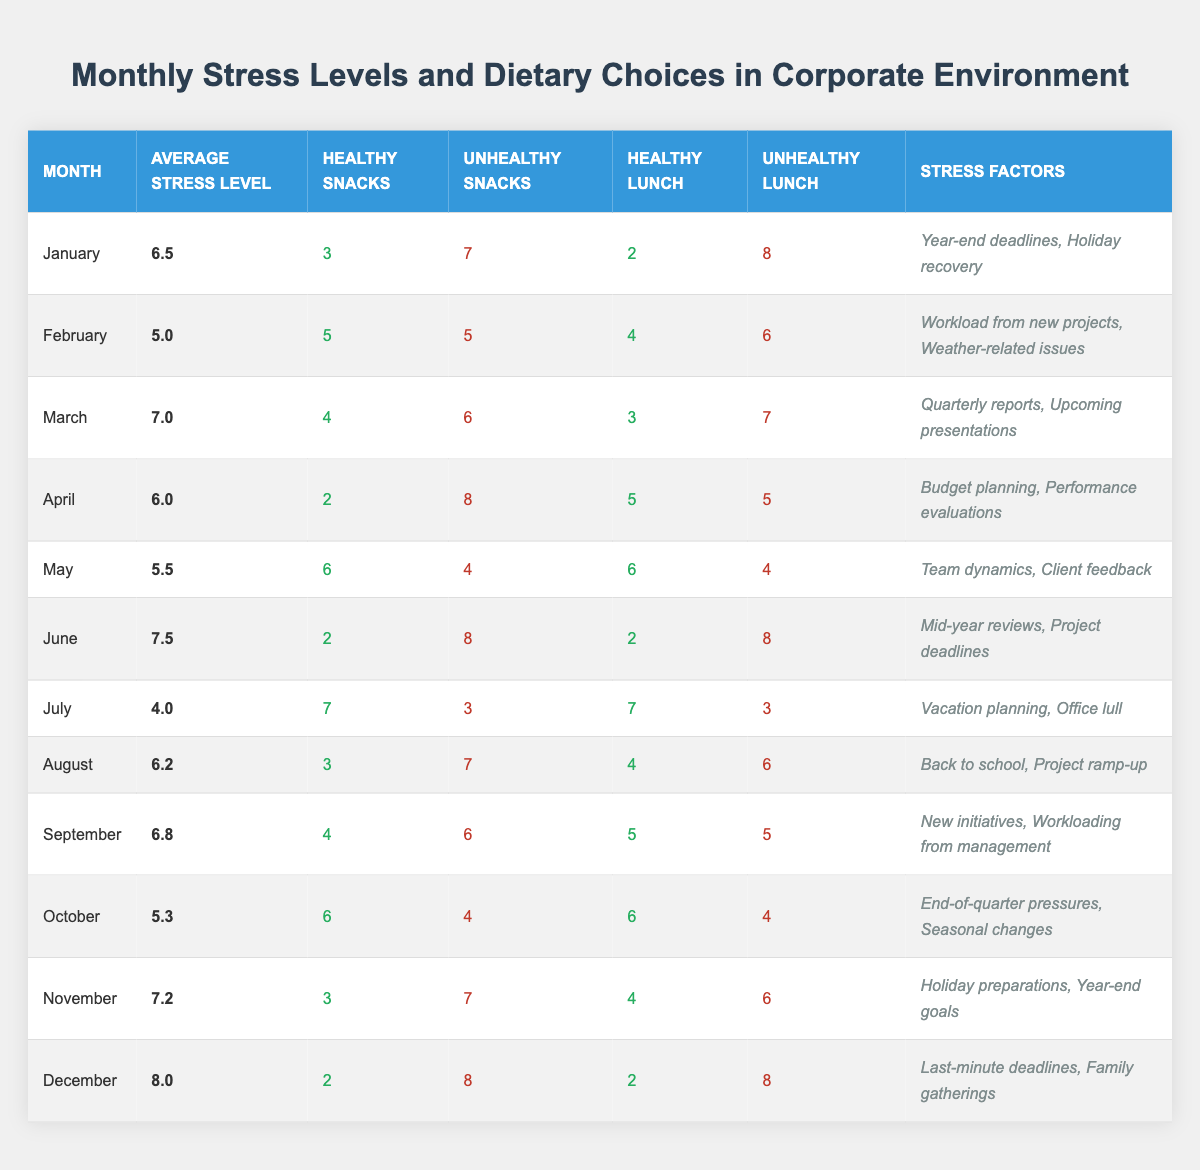What was the average stress level in February? In the table, the average stress level for February is listed directly in that row as 5.0.
Answer: 5.0 How many unhealthy snacks were consumed in March? Looking at the table for March, the number of unhealthy snacks is listed as 6.
Answer: 6 What is the average number of healthy lunch options across all months? To find the average, we sum the healthy lunch options for each month (2 + 4 + 3 + 5 + 6 + 2 + 7 + 4 + 5 + 6 + 4 + 2 = 58) and divide by the number of months (12). So, 58/12 = 4.83.
Answer: 4.83 In which month did the highest average stress level occur? The stress levels are compared, and December has the highest average stress level at 8.0, which is greater than all other months.
Answer: December How many months recorded an average stress level above 7.0? By checking the table, the months with stress levels above 7.0 are March (7.0), June (7.5), November (7.2), and December (8.0). This totals 4 months.
Answer: 4 Was January's average stress level higher than that of July? Comparing the two values, January had an average stress level of 6.5 and July had 4.0, meaning January's level was higher.
Answer: Yes What was the difference in unhealthy lunch choices between June and July? For June, unhealthy lunch choices were 8, and for July, they were 3. The difference is calculated as 8 - 3 = 5.
Answer: 5 During which month were the most healthy snacks consumed? The table indicates that in July, there were 7 healthy snacks consumed, which is the highest compared to other months.
Answer: July What is the total number of unhealthy snacks consumed in the first half of the year (January to June)? The total for unhealthy snacks in the first half is calculated as follows: January (7) + February (5) + March (6) + April (8) + May (4) + June (8) = 38.
Answer: 38 Which month had the lowest average stress level, and what was the factor contributing to it? July had the lowest average stress level of 4.0, primarily due to the stress factors being related to vacation planning and the office lull.
Answer: July, vacation planning and office lull 